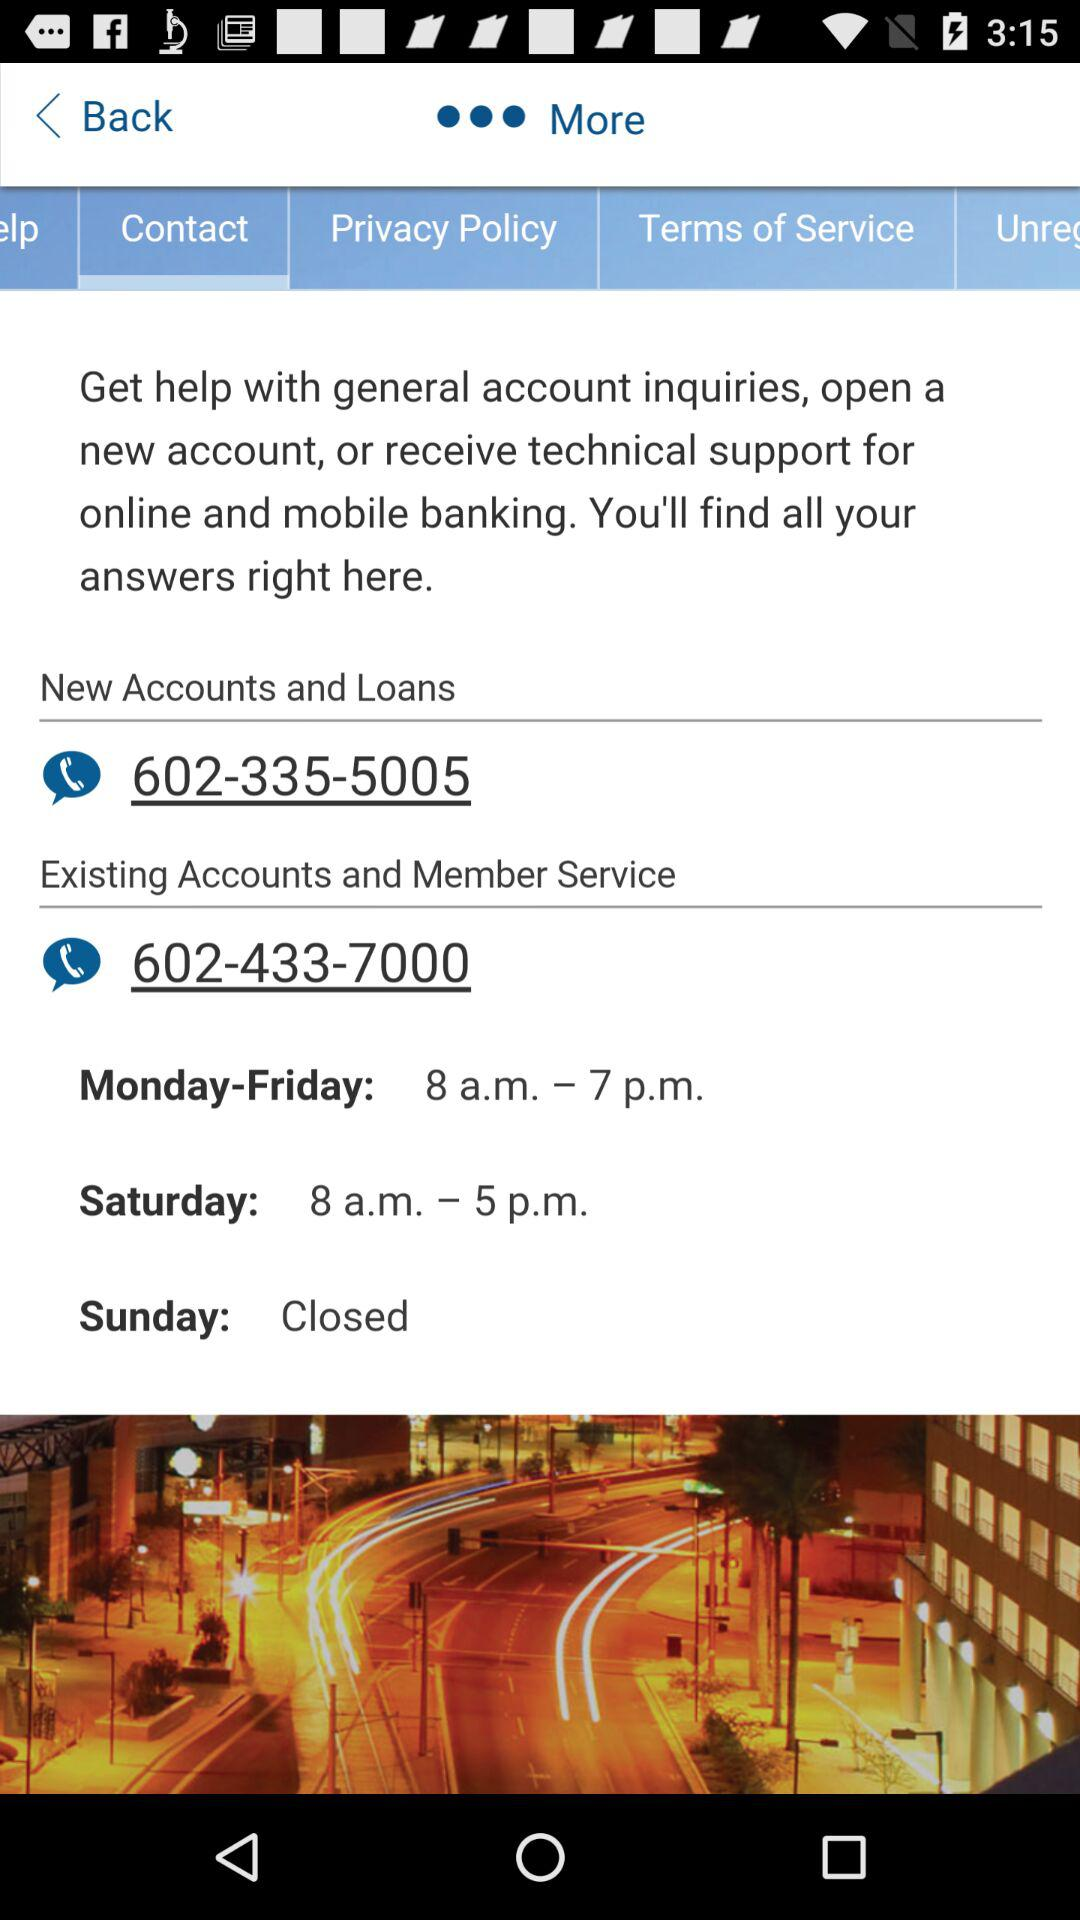Which tab is selected? The selected tab is "Contact". 